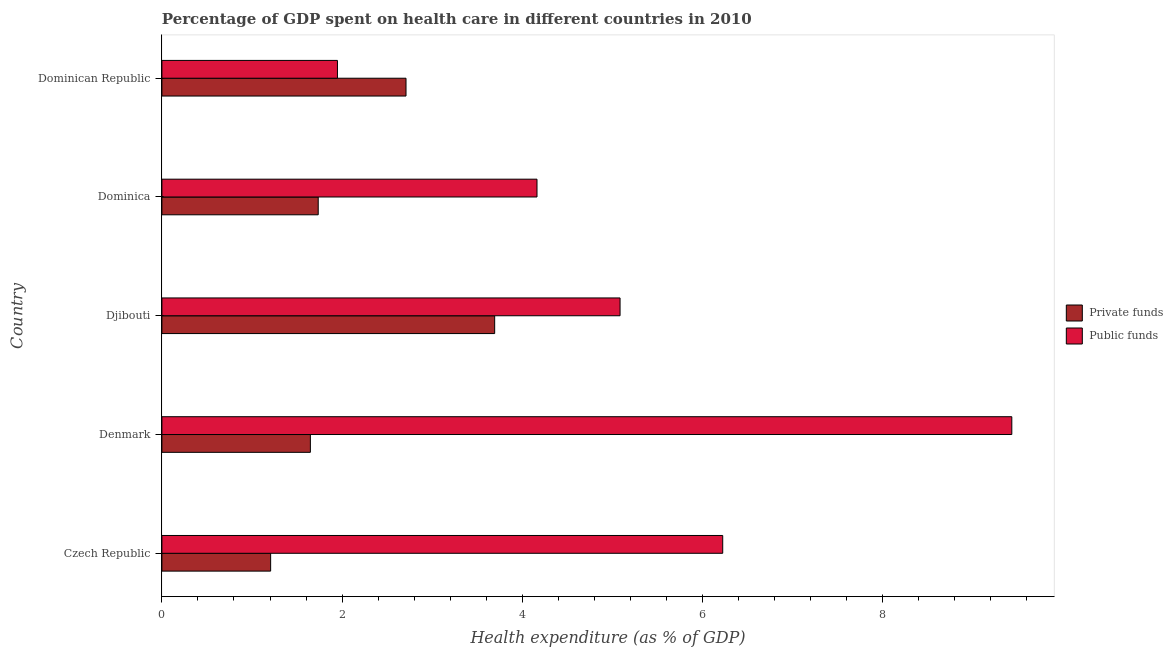How many bars are there on the 1st tick from the top?
Keep it short and to the point. 2. What is the label of the 3rd group of bars from the top?
Make the answer very short. Djibouti. In how many cases, is the number of bars for a given country not equal to the number of legend labels?
Keep it short and to the point. 0. What is the amount of private funds spent in healthcare in Denmark?
Offer a very short reply. 1.65. Across all countries, what is the maximum amount of private funds spent in healthcare?
Offer a very short reply. 3.69. Across all countries, what is the minimum amount of public funds spent in healthcare?
Provide a short and direct response. 1.95. In which country was the amount of private funds spent in healthcare minimum?
Ensure brevity in your answer.  Czech Republic. What is the total amount of private funds spent in healthcare in the graph?
Your answer should be very brief. 10.99. What is the difference between the amount of public funds spent in healthcare in Czech Republic and that in Denmark?
Your answer should be compact. -3.21. What is the difference between the amount of public funds spent in healthcare in Dominican Republic and the amount of private funds spent in healthcare in Dominica?
Offer a terse response. 0.21. What is the average amount of public funds spent in healthcare per country?
Keep it short and to the point. 5.37. What is the difference between the amount of private funds spent in healthcare and amount of public funds spent in healthcare in Djibouti?
Offer a terse response. -1.39. What is the ratio of the amount of private funds spent in healthcare in Dominica to that in Dominican Republic?
Provide a short and direct response. 0.64. Is the amount of private funds spent in healthcare in Czech Republic less than that in Djibouti?
Provide a short and direct response. Yes. What is the difference between the highest and the lowest amount of private funds spent in healthcare?
Offer a very short reply. 2.49. In how many countries, is the amount of public funds spent in healthcare greater than the average amount of public funds spent in healthcare taken over all countries?
Keep it short and to the point. 2. Is the sum of the amount of private funds spent in healthcare in Denmark and Dominican Republic greater than the maximum amount of public funds spent in healthcare across all countries?
Offer a very short reply. No. What does the 2nd bar from the top in Denmark represents?
Your answer should be compact. Private funds. What does the 2nd bar from the bottom in Djibouti represents?
Your answer should be very brief. Public funds. How many countries are there in the graph?
Offer a very short reply. 5. Are the values on the major ticks of X-axis written in scientific E-notation?
Offer a terse response. No. Does the graph contain grids?
Make the answer very short. No. Where does the legend appear in the graph?
Ensure brevity in your answer.  Center right. How many legend labels are there?
Give a very brief answer. 2. What is the title of the graph?
Offer a very short reply. Percentage of GDP spent on health care in different countries in 2010. What is the label or title of the X-axis?
Give a very brief answer. Health expenditure (as % of GDP). What is the Health expenditure (as % of GDP) of Private funds in Czech Republic?
Your response must be concise. 1.21. What is the Health expenditure (as % of GDP) of Public funds in Czech Republic?
Provide a succinct answer. 6.22. What is the Health expenditure (as % of GDP) in Private funds in Denmark?
Make the answer very short. 1.65. What is the Health expenditure (as % of GDP) of Public funds in Denmark?
Make the answer very short. 9.43. What is the Health expenditure (as % of GDP) of Private funds in Djibouti?
Offer a very short reply. 3.69. What is the Health expenditure (as % of GDP) in Public funds in Djibouti?
Keep it short and to the point. 5.09. What is the Health expenditure (as % of GDP) in Private funds in Dominica?
Provide a succinct answer. 1.74. What is the Health expenditure (as % of GDP) in Public funds in Dominica?
Ensure brevity in your answer.  4.16. What is the Health expenditure (as % of GDP) in Private funds in Dominican Republic?
Your answer should be compact. 2.71. What is the Health expenditure (as % of GDP) of Public funds in Dominican Republic?
Ensure brevity in your answer.  1.95. Across all countries, what is the maximum Health expenditure (as % of GDP) of Private funds?
Provide a short and direct response. 3.69. Across all countries, what is the maximum Health expenditure (as % of GDP) in Public funds?
Offer a terse response. 9.43. Across all countries, what is the minimum Health expenditure (as % of GDP) in Private funds?
Keep it short and to the point. 1.21. Across all countries, what is the minimum Health expenditure (as % of GDP) in Public funds?
Ensure brevity in your answer.  1.95. What is the total Health expenditure (as % of GDP) of Private funds in the graph?
Make the answer very short. 10.99. What is the total Health expenditure (as % of GDP) in Public funds in the graph?
Keep it short and to the point. 26.86. What is the difference between the Health expenditure (as % of GDP) of Private funds in Czech Republic and that in Denmark?
Provide a succinct answer. -0.44. What is the difference between the Health expenditure (as % of GDP) in Public funds in Czech Republic and that in Denmark?
Give a very brief answer. -3.21. What is the difference between the Health expenditure (as % of GDP) in Private funds in Czech Republic and that in Djibouti?
Ensure brevity in your answer.  -2.49. What is the difference between the Health expenditure (as % of GDP) in Public funds in Czech Republic and that in Djibouti?
Give a very brief answer. 1.14. What is the difference between the Health expenditure (as % of GDP) of Private funds in Czech Republic and that in Dominica?
Your answer should be very brief. -0.53. What is the difference between the Health expenditure (as % of GDP) in Public funds in Czech Republic and that in Dominica?
Your answer should be compact. 2.06. What is the difference between the Health expenditure (as % of GDP) in Private funds in Czech Republic and that in Dominican Republic?
Your answer should be very brief. -1.5. What is the difference between the Health expenditure (as % of GDP) in Public funds in Czech Republic and that in Dominican Republic?
Keep it short and to the point. 4.28. What is the difference between the Health expenditure (as % of GDP) in Private funds in Denmark and that in Djibouti?
Make the answer very short. -2.05. What is the difference between the Health expenditure (as % of GDP) of Public funds in Denmark and that in Djibouti?
Your answer should be very brief. 4.35. What is the difference between the Health expenditure (as % of GDP) of Private funds in Denmark and that in Dominica?
Provide a short and direct response. -0.09. What is the difference between the Health expenditure (as % of GDP) of Public funds in Denmark and that in Dominica?
Offer a terse response. 5.27. What is the difference between the Health expenditure (as % of GDP) in Private funds in Denmark and that in Dominican Republic?
Make the answer very short. -1.06. What is the difference between the Health expenditure (as % of GDP) in Public funds in Denmark and that in Dominican Republic?
Make the answer very short. 7.49. What is the difference between the Health expenditure (as % of GDP) in Private funds in Djibouti and that in Dominica?
Your answer should be very brief. 1.96. What is the difference between the Health expenditure (as % of GDP) of Public funds in Djibouti and that in Dominica?
Your answer should be compact. 0.92. What is the difference between the Health expenditure (as % of GDP) in Private funds in Djibouti and that in Dominican Republic?
Ensure brevity in your answer.  0.98. What is the difference between the Health expenditure (as % of GDP) in Public funds in Djibouti and that in Dominican Republic?
Your answer should be very brief. 3.14. What is the difference between the Health expenditure (as % of GDP) of Private funds in Dominica and that in Dominican Republic?
Provide a short and direct response. -0.97. What is the difference between the Health expenditure (as % of GDP) of Public funds in Dominica and that in Dominican Republic?
Make the answer very short. 2.21. What is the difference between the Health expenditure (as % of GDP) of Private funds in Czech Republic and the Health expenditure (as % of GDP) of Public funds in Denmark?
Provide a short and direct response. -8.23. What is the difference between the Health expenditure (as % of GDP) in Private funds in Czech Republic and the Health expenditure (as % of GDP) in Public funds in Djibouti?
Offer a terse response. -3.88. What is the difference between the Health expenditure (as % of GDP) of Private funds in Czech Republic and the Health expenditure (as % of GDP) of Public funds in Dominica?
Keep it short and to the point. -2.96. What is the difference between the Health expenditure (as % of GDP) in Private funds in Czech Republic and the Health expenditure (as % of GDP) in Public funds in Dominican Republic?
Offer a very short reply. -0.74. What is the difference between the Health expenditure (as % of GDP) in Private funds in Denmark and the Health expenditure (as % of GDP) in Public funds in Djibouti?
Give a very brief answer. -3.44. What is the difference between the Health expenditure (as % of GDP) in Private funds in Denmark and the Health expenditure (as % of GDP) in Public funds in Dominica?
Offer a terse response. -2.52. What is the difference between the Health expenditure (as % of GDP) in Private funds in Denmark and the Health expenditure (as % of GDP) in Public funds in Dominican Republic?
Your answer should be very brief. -0.3. What is the difference between the Health expenditure (as % of GDP) of Private funds in Djibouti and the Health expenditure (as % of GDP) of Public funds in Dominica?
Ensure brevity in your answer.  -0.47. What is the difference between the Health expenditure (as % of GDP) in Private funds in Djibouti and the Health expenditure (as % of GDP) in Public funds in Dominican Republic?
Provide a short and direct response. 1.75. What is the difference between the Health expenditure (as % of GDP) of Private funds in Dominica and the Health expenditure (as % of GDP) of Public funds in Dominican Republic?
Offer a very short reply. -0.21. What is the average Health expenditure (as % of GDP) in Private funds per country?
Ensure brevity in your answer.  2.2. What is the average Health expenditure (as % of GDP) of Public funds per country?
Your answer should be compact. 5.37. What is the difference between the Health expenditure (as % of GDP) of Private funds and Health expenditure (as % of GDP) of Public funds in Czech Republic?
Ensure brevity in your answer.  -5.02. What is the difference between the Health expenditure (as % of GDP) in Private funds and Health expenditure (as % of GDP) in Public funds in Denmark?
Provide a succinct answer. -7.79. What is the difference between the Health expenditure (as % of GDP) in Private funds and Health expenditure (as % of GDP) in Public funds in Djibouti?
Your response must be concise. -1.39. What is the difference between the Health expenditure (as % of GDP) of Private funds and Health expenditure (as % of GDP) of Public funds in Dominica?
Make the answer very short. -2.43. What is the difference between the Health expenditure (as % of GDP) in Private funds and Health expenditure (as % of GDP) in Public funds in Dominican Republic?
Your answer should be compact. 0.76. What is the ratio of the Health expenditure (as % of GDP) of Private funds in Czech Republic to that in Denmark?
Give a very brief answer. 0.73. What is the ratio of the Health expenditure (as % of GDP) in Public funds in Czech Republic to that in Denmark?
Keep it short and to the point. 0.66. What is the ratio of the Health expenditure (as % of GDP) of Private funds in Czech Republic to that in Djibouti?
Provide a short and direct response. 0.33. What is the ratio of the Health expenditure (as % of GDP) in Public funds in Czech Republic to that in Djibouti?
Give a very brief answer. 1.22. What is the ratio of the Health expenditure (as % of GDP) in Private funds in Czech Republic to that in Dominica?
Your answer should be compact. 0.7. What is the ratio of the Health expenditure (as % of GDP) of Public funds in Czech Republic to that in Dominica?
Your answer should be compact. 1.5. What is the ratio of the Health expenditure (as % of GDP) in Private funds in Czech Republic to that in Dominican Republic?
Your response must be concise. 0.45. What is the ratio of the Health expenditure (as % of GDP) in Public funds in Czech Republic to that in Dominican Republic?
Ensure brevity in your answer.  3.19. What is the ratio of the Health expenditure (as % of GDP) of Private funds in Denmark to that in Djibouti?
Provide a succinct answer. 0.45. What is the ratio of the Health expenditure (as % of GDP) of Public funds in Denmark to that in Djibouti?
Provide a succinct answer. 1.85. What is the ratio of the Health expenditure (as % of GDP) of Private funds in Denmark to that in Dominica?
Give a very brief answer. 0.95. What is the ratio of the Health expenditure (as % of GDP) of Public funds in Denmark to that in Dominica?
Your answer should be compact. 2.27. What is the ratio of the Health expenditure (as % of GDP) in Private funds in Denmark to that in Dominican Republic?
Give a very brief answer. 0.61. What is the ratio of the Health expenditure (as % of GDP) in Public funds in Denmark to that in Dominican Republic?
Your answer should be very brief. 4.84. What is the ratio of the Health expenditure (as % of GDP) in Private funds in Djibouti to that in Dominica?
Offer a terse response. 2.13. What is the ratio of the Health expenditure (as % of GDP) in Public funds in Djibouti to that in Dominica?
Make the answer very short. 1.22. What is the ratio of the Health expenditure (as % of GDP) in Private funds in Djibouti to that in Dominican Republic?
Make the answer very short. 1.36. What is the ratio of the Health expenditure (as % of GDP) of Public funds in Djibouti to that in Dominican Republic?
Offer a very short reply. 2.61. What is the ratio of the Health expenditure (as % of GDP) in Private funds in Dominica to that in Dominican Republic?
Keep it short and to the point. 0.64. What is the ratio of the Health expenditure (as % of GDP) of Public funds in Dominica to that in Dominican Republic?
Ensure brevity in your answer.  2.14. What is the difference between the highest and the second highest Health expenditure (as % of GDP) in Private funds?
Your answer should be very brief. 0.98. What is the difference between the highest and the second highest Health expenditure (as % of GDP) of Public funds?
Offer a terse response. 3.21. What is the difference between the highest and the lowest Health expenditure (as % of GDP) of Private funds?
Keep it short and to the point. 2.49. What is the difference between the highest and the lowest Health expenditure (as % of GDP) of Public funds?
Give a very brief answer. 7.49. 